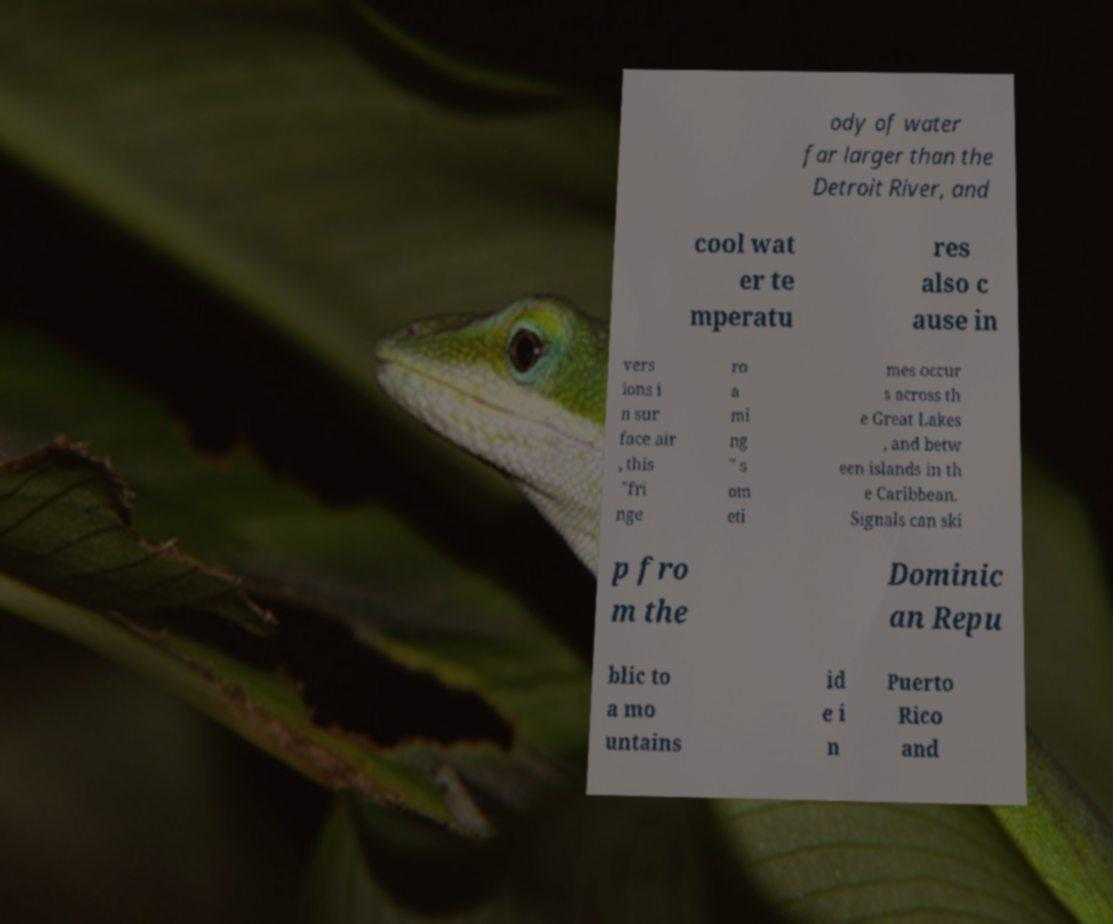For documentation purposes, I need the text within this image transcribed. Could you provide that? ody of water far larger than the Detroit River, and cool wat er te mperatu res also c ause in vers ions i n sur face air , this "fri nge ro a mi ng " s om eti mes occur s across th e Great Lakes , and betw een islands in th e Caribbean. Signals can ski p fro m the Dominic an Repu blic to a mo untains id e i n Puerto Rico and 